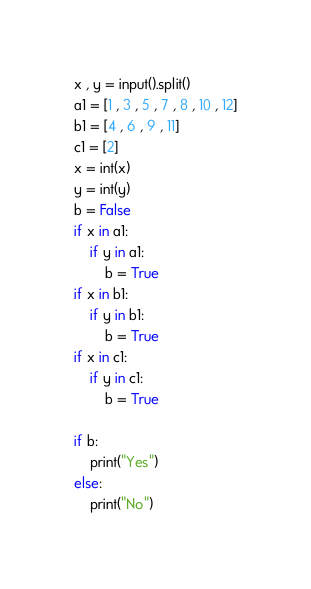<code> <loc_0><loc_0><loc_500><loc_500><_Python_>x , y = input().split()
a1 = [1 , 3 , 5 , 7 , 8 , 10 , 12]
b1 = [4 , 6 , 9 , 11]
c1 = [2]
x = int(x)
y = int(y)
b = False
if x in a1:
    if y in a1:
        b = True
if x in b1:
    if y in b1:
        b = True
if x in c1:
    if y in c1:
        b = True

if b:
    print("Yes")
else:
    print("No")
</code> 